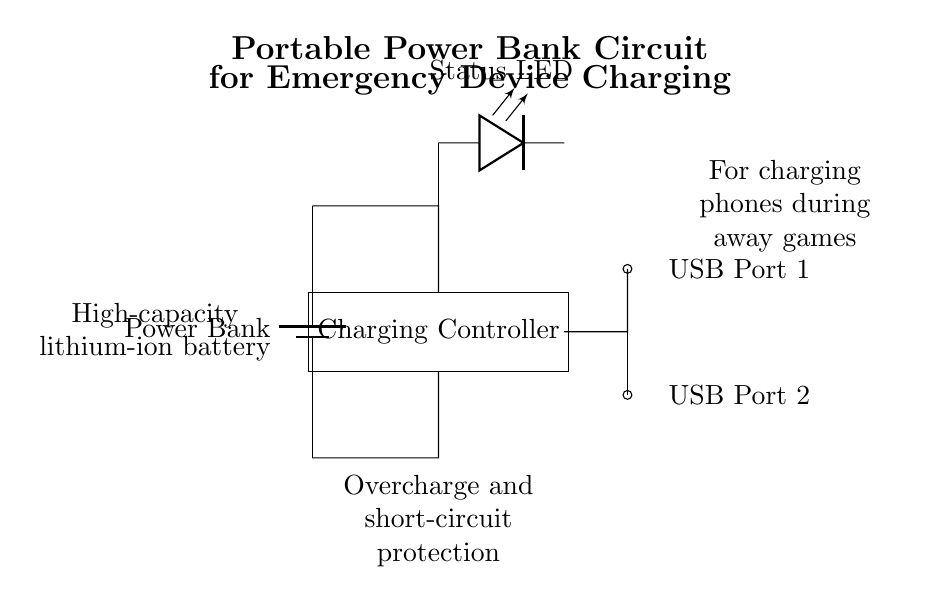What is the main component in this circuit? The main component is the power bank, which serves as the source of power for the circuit. It is depicted as a vertical battery symbol in the drawing.
Answer: Power Bank How many USB ports are present? The diagram shows two distinct USB ports indicated on the right side, labeled USB Port 1 and USB Port 2.
Answer: Two What function does the Charging Controller serve? The Charging Controller regulates the charging process of devices connected to the USB ports to ensure safe and efficient charging. Its placement suggests it is a crucial intermediary between the power bank and USB ports.
Answer: Regulates charging What does the Status LED indicate? The Status LED provides visual feedback about the operation of the circuit, indicating whether the power bank is currently charging devices or is in a standby state. Its presence in the circuit suggests a user-friendly feature.
Answer: Charging status What kind of battery is used in this circuit? The circuit includes a high-capacity lithium-ion battery, which is noted in an annotation, commonly used in power banks due to its high energy density and rechargeability.
Answer: Lithium-ion Why is overcharge protection important in this circuit? Overcharge protection prevents excessive charging of devices connected to USB ports, which can lead to overheating and potentially damaging the devices. This protection mechanism ensures safe operation and longevity of both the devices and the power bank.
Answer: Prevents damage 